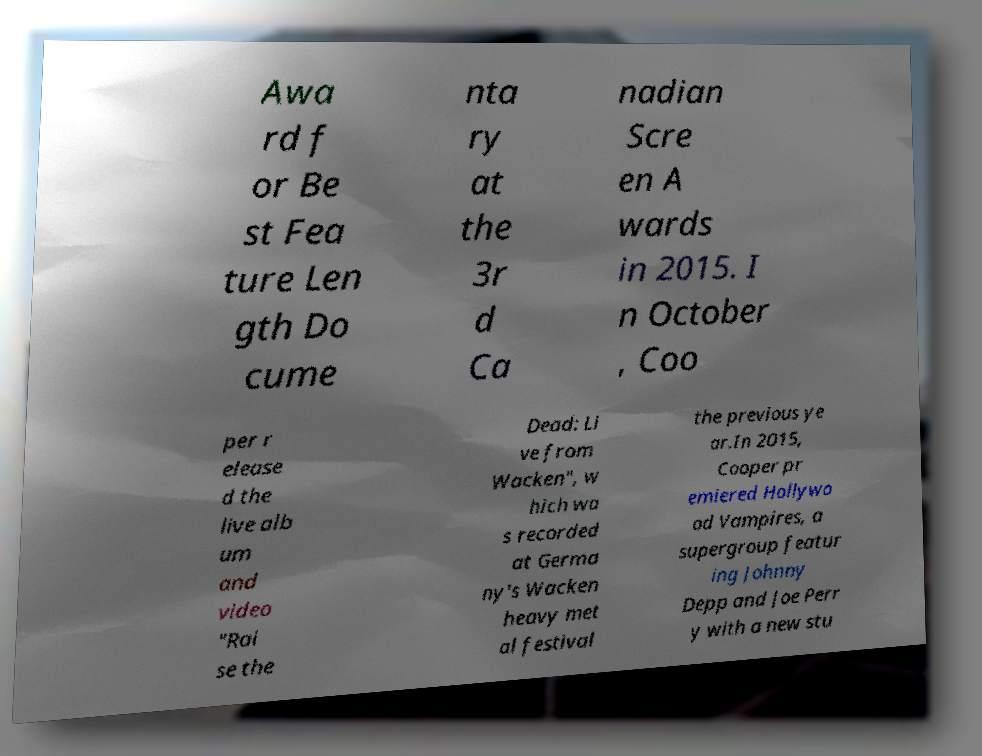What messages or text are displayed in this image? I need them in a readable, typed format. Awa rd f or Be st Fea ture Len gth Do cume nta ry at the 3r d Ca nadian Scre en A wards in 2015. I n October , Coo per r elease d the live alb um and video "Rai se the Dead: Li ve from Wacken", w hich wa s recorded at Germa ny's Wacken heavy met al festival the previous ye ar.In 2015, Cooper pr emiered Hollywo od Vampires, a supergroup featur ing Johnny Depp and Joe Perr y with a new stu 